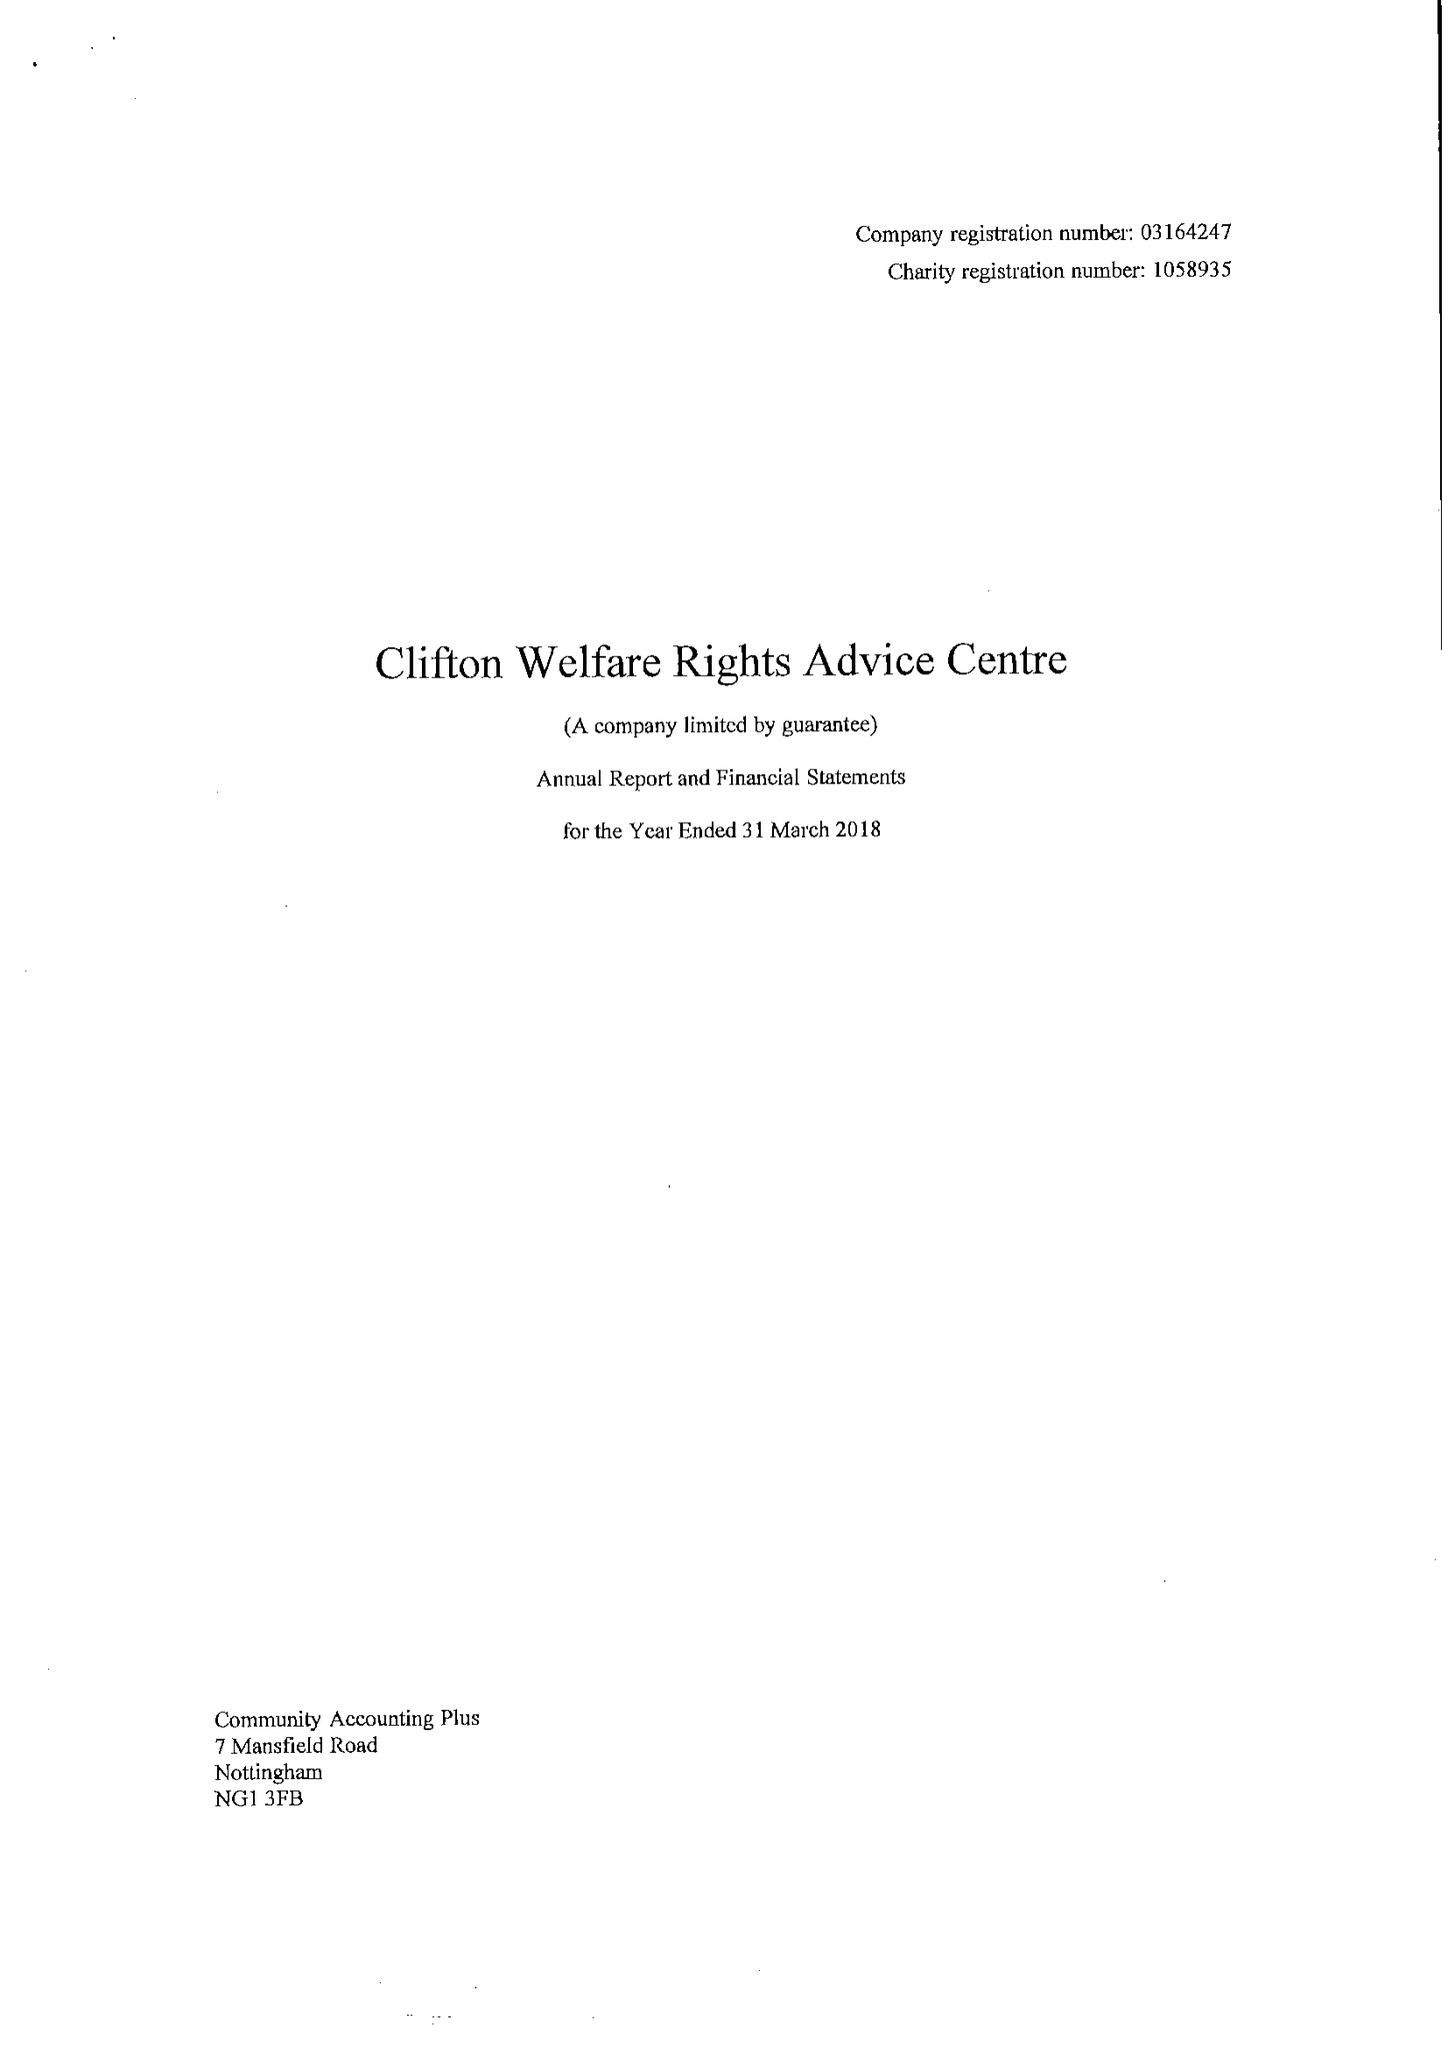What is the value for the report_date?
Answer the question using a single word or phrase. 2018-03-31 